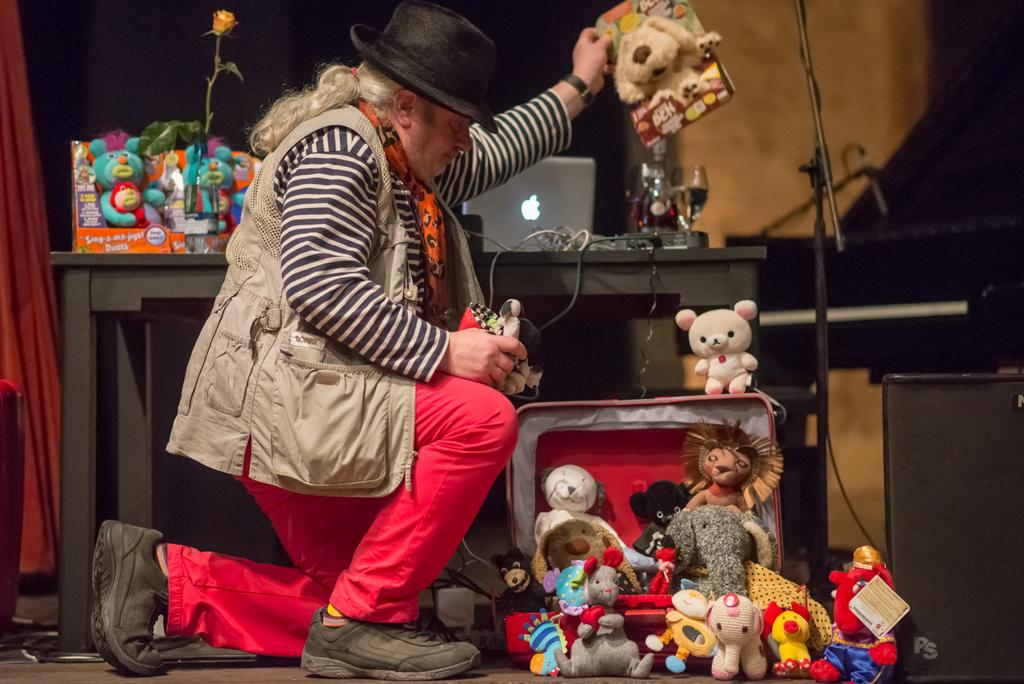What is one of the main features of the image? There is a wall in the image. What can be seen growing on the wall? There is a flower in the image. What electronic device is visible in the image? There is a laptop in the image. Can you describe the person in the image? The person is wearing a black color hat, a cream color jacket, and black color shoes. What type of furniture is present in the image? There are tables in the image. What type of items are present for children's entertainment? There are toys in the image. How does the girl interact with the jelly in the image? There is no girl or jelly present in the image. What type of play is the person engaged in with the toys in the image? The text does not mention any play or interaction with the toys; the person is simply near them. 